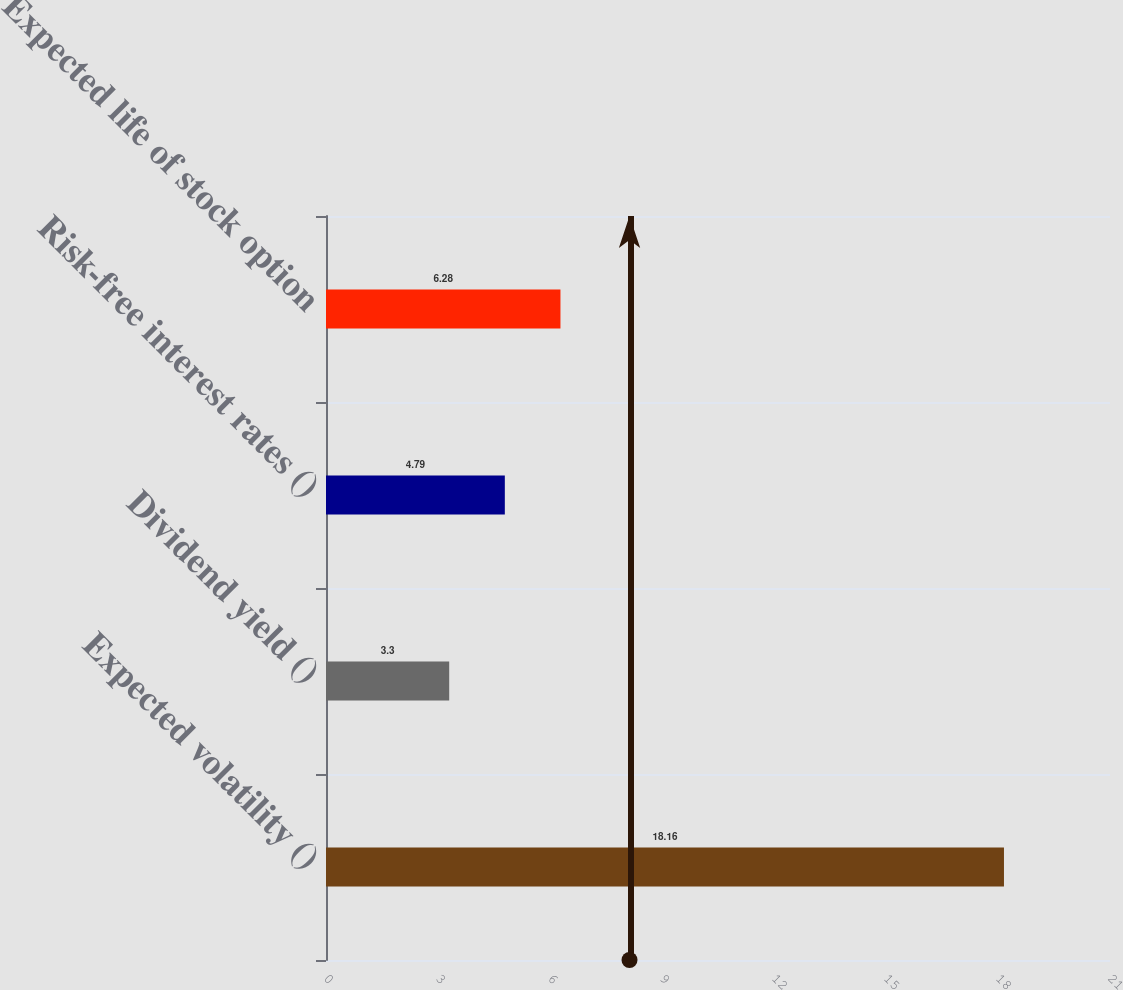<chart> <loc_0><loc_0><loc_500><loc_500><bar_chart><fcel>Expected volatility ()<fcel>Dividend yield ()<fcel>Risk-free interest rates ()<fcel>Expected life of stock option<nl><fcel>18.16<fcel>3.3<fcel>4.79<fcel>6.28<nl></chart> 